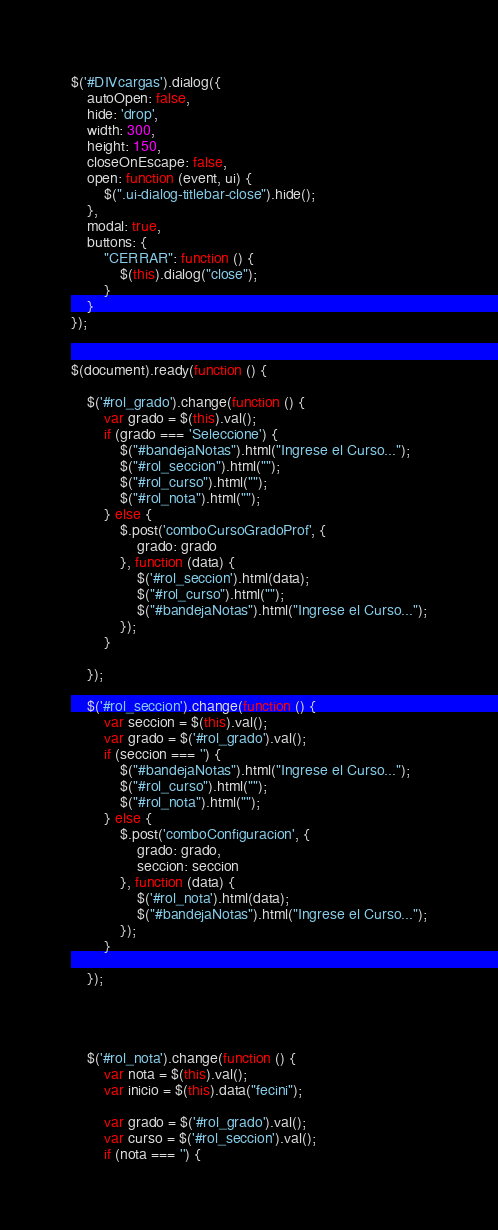Convert code to text. <code><loc_0><loc_0><loc_500><loc_500><_JavaScript_>$('#DIVcargas').dialog({
    autoOpen: false,
    hide: 'drop',
    width: 300,
    height: 150,
    closeOnEscape: false,
    open: function (event, ui) {
        $(".ui-dialog-titlebar-close").hide();
    },
    modal: true,
    buttons: {
        "CERRAR": function () {
            $(this).dialog("close");
        }
    }
});


$(document).ready(function () {

    $('#rol_grado').change(function () {
        var grado = $(this).val();
        if (grado === 'Seleccione') {
            $("#bandejaNotas").html("Ingrese el Curso...");
            $("#rol_seccion").html("");
            $("#rol_curso").html("");
            $("#rol_nota").html("");
        } else {
            $.post('comboCursoGradoProf', {
                grado: grado
            }, function (data) {
                $('#rol_seccion').html(data);
                $("#rol_curso").html("");
                $("#bandejaNotas").html("Ingrese el Curso...");
            });
        }

    });

    $('#rol_seccion').change(function () {
        var seccion = $(this).val();
        var grado = $('#rol_grado').val();
        if (seccion === '') {
            $("#bandejaNotas").html("Ingrese el Curso...");
            $("#rol_curso").html("");
            $("#rol_nota").html("");
        } else {
            $.post('comboConfiguracion', {
                grado: grado,
                seccion: seccion
            }, function (data) {
                $('#rol_nota').html(data);
                $("#bandejaNotas").html("Ingrese el Curso...");
            });
        }

    });




    $('#rol_nota').change(function () {
        var nota = $(this).val();
        var inicio = $(this).data("fecini");

        var grado = $('#rol_grado').val();
        var curso = $('#rol_seccion').val();
        if (nota === '') {</code> 